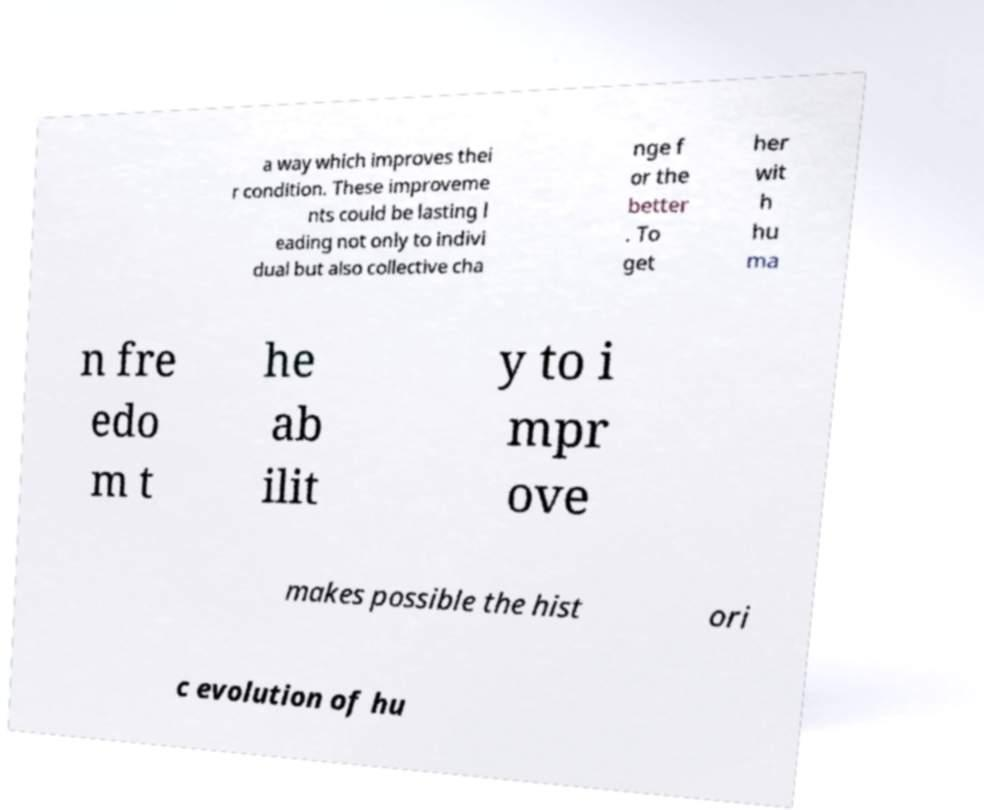There's text embedded in this image that I need extracted. Can you transcribe it verbatim? a way which improves thei r condition. These improveme nts could be lasting l eading not only to indivi dual but also collective cha nge f or the better . To get her wit h hu ma n fre edo m t he ab ilit y to i mpr ove makes possible the hist ori c evolution of hu 